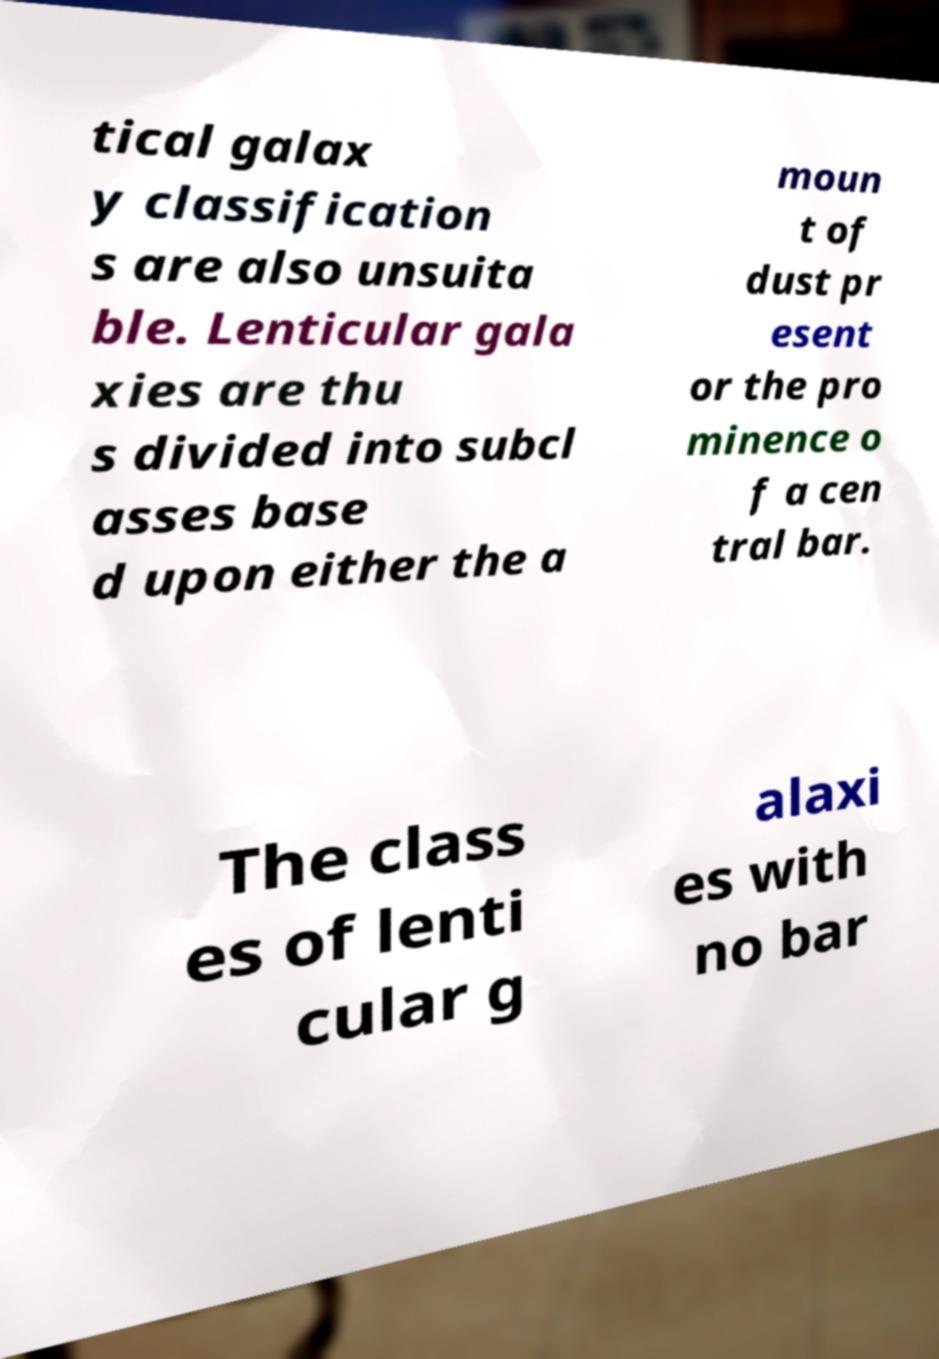What messages or text are displayed in this image? I need them in a readable, typed format. tical galax y classification s are also unsuita ble. Lenticular gala xies are thu s divided into subcl asses base d upon either the a moun t of dust pr esent or the pro minence o f a cen tral bar. The class es of lenti cular g alaxi es with no bar 